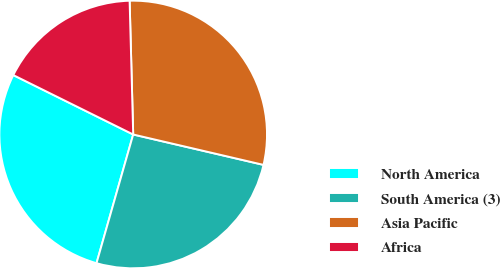Convert chart. <chart><loc_0><loc_0><loc_500><loc_500><pie_chart><fcel>North America<fcel>South America (3)<fcel>Asia Pacific<fcel>Africa<nl><fcel>27.9%<fcel>25.77%<fcel>29.07%<fcel>17.25%<nl></chart> 